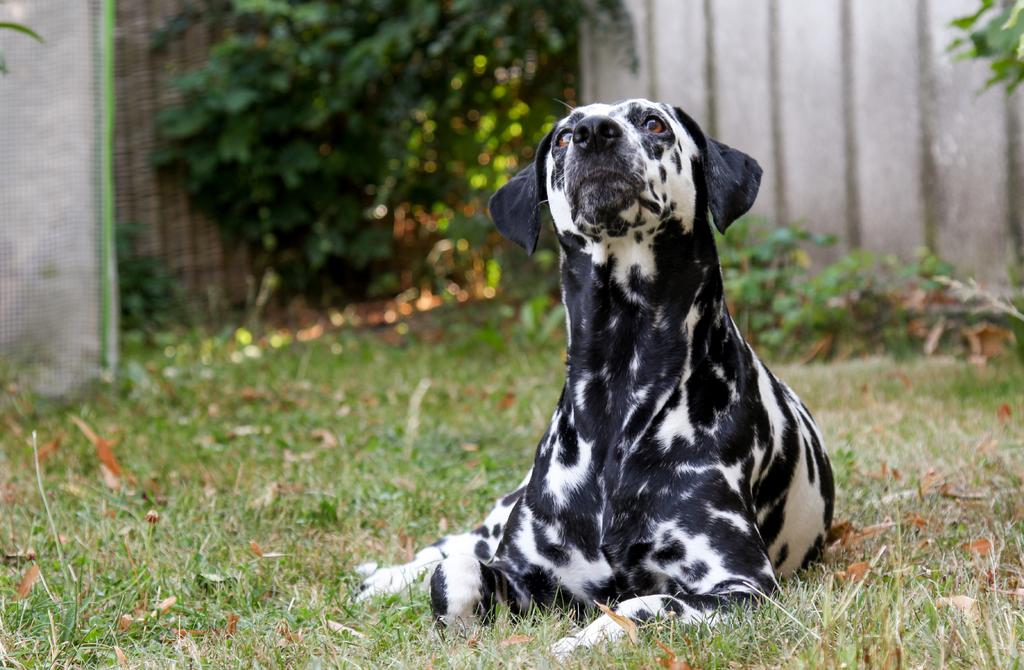What is the main subject of the image? There is a dog sitting on the floor in the image. What is the floor made of in the image? There is grass on the floor in the image. What can be seen in the backdrop of the image? There are plants and a wall in the backdrop of the image. What type of wine is the dog drinking in the image? There is no wine present in the image; the dog is sitting on the grass. What kind of record is the dog playing in the image? There is no record player or record present in the image; the dog is simply sitting on the grass. 